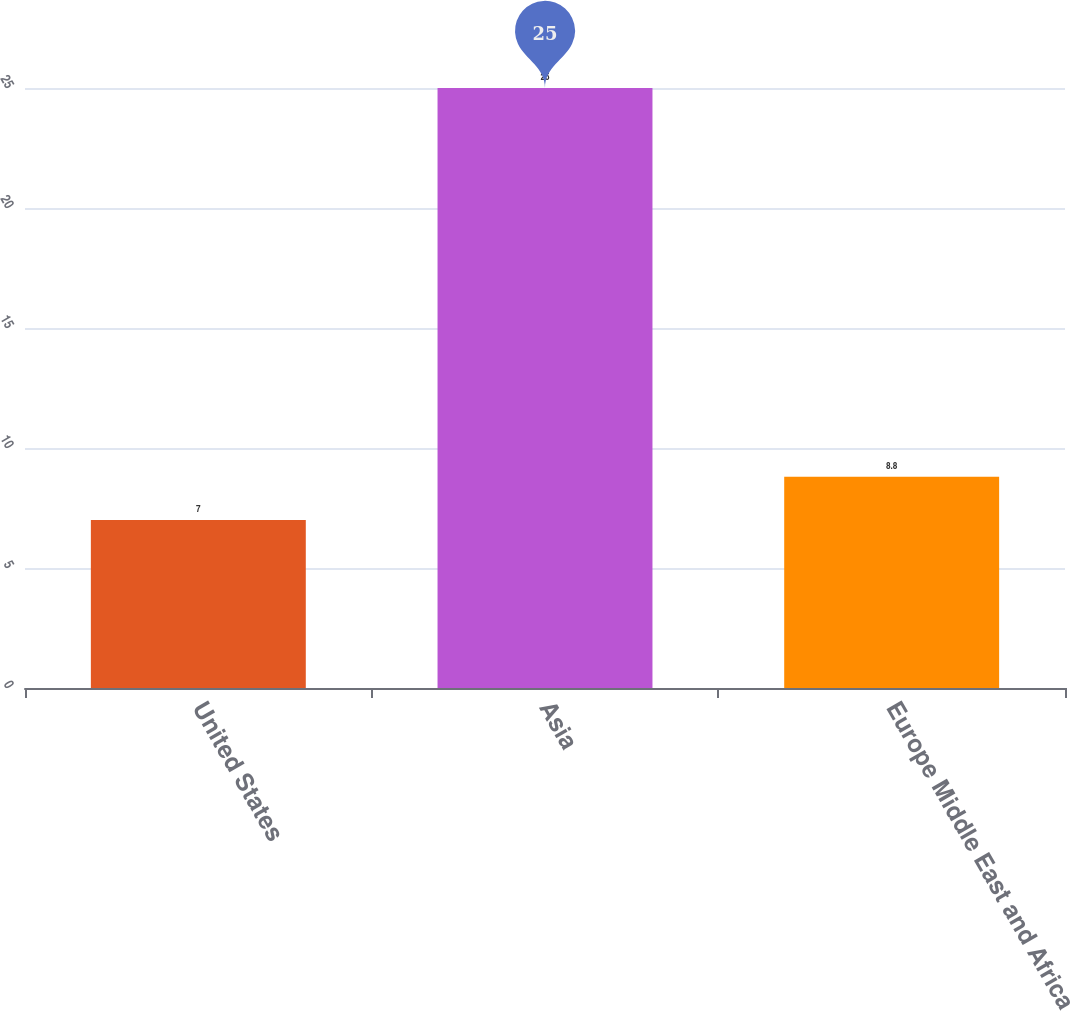Convert chart to OTSL. <chart><loc_0><loc_0><loc_500><loc_500><bar_chart><fcel>United States<fcel>Asia<fcel>Europe Middle East and Africa<nl><fcel>7<fcel>25<fcel>8.8<nl></chart> 